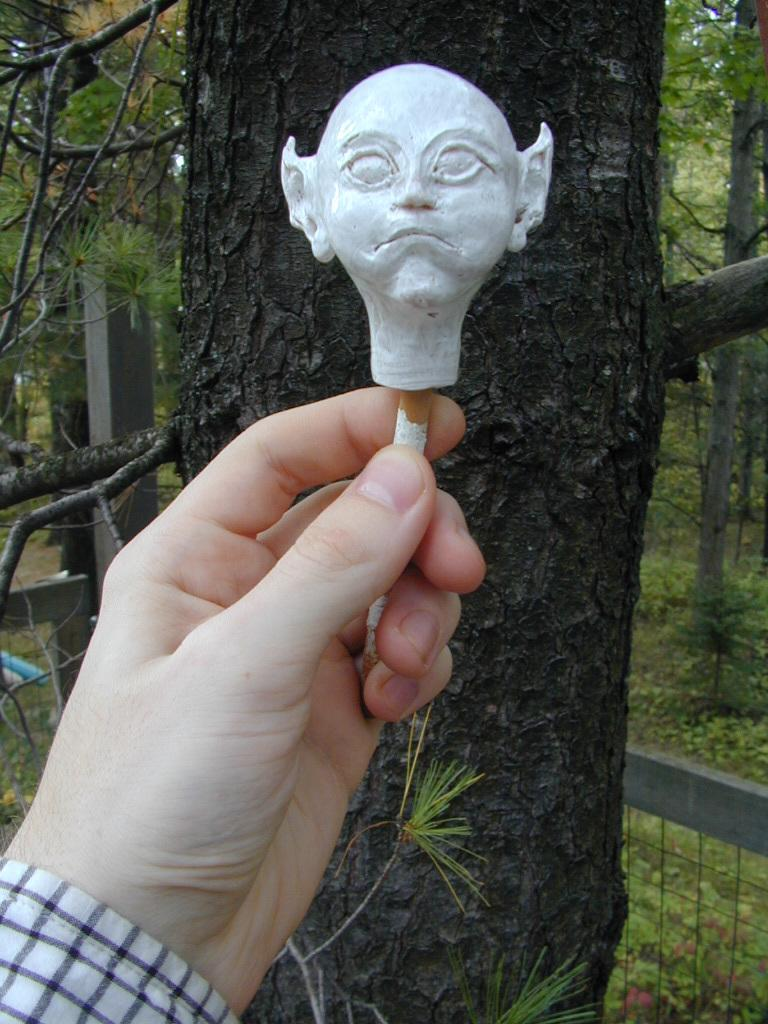What can be seen in the front of the image? There is a person's hand in the front of the image. What is the person holding in their hand? The person is holding a head mount. What type of natural environment is visible in the background of the image? There are trees in the background of the image. What type of vegetation is visible at the bottom of the image? There are plants visible at the bottom of the image. What type of chess piece is visible on the person's hand in the image? There is no chess piece visible on the person's hand in the image; they are holding a head mount. What color is the ink used to write on the plants in the image? There is no ink or writing present on the plants in the image; they are simply visible at the bottom of the image. 